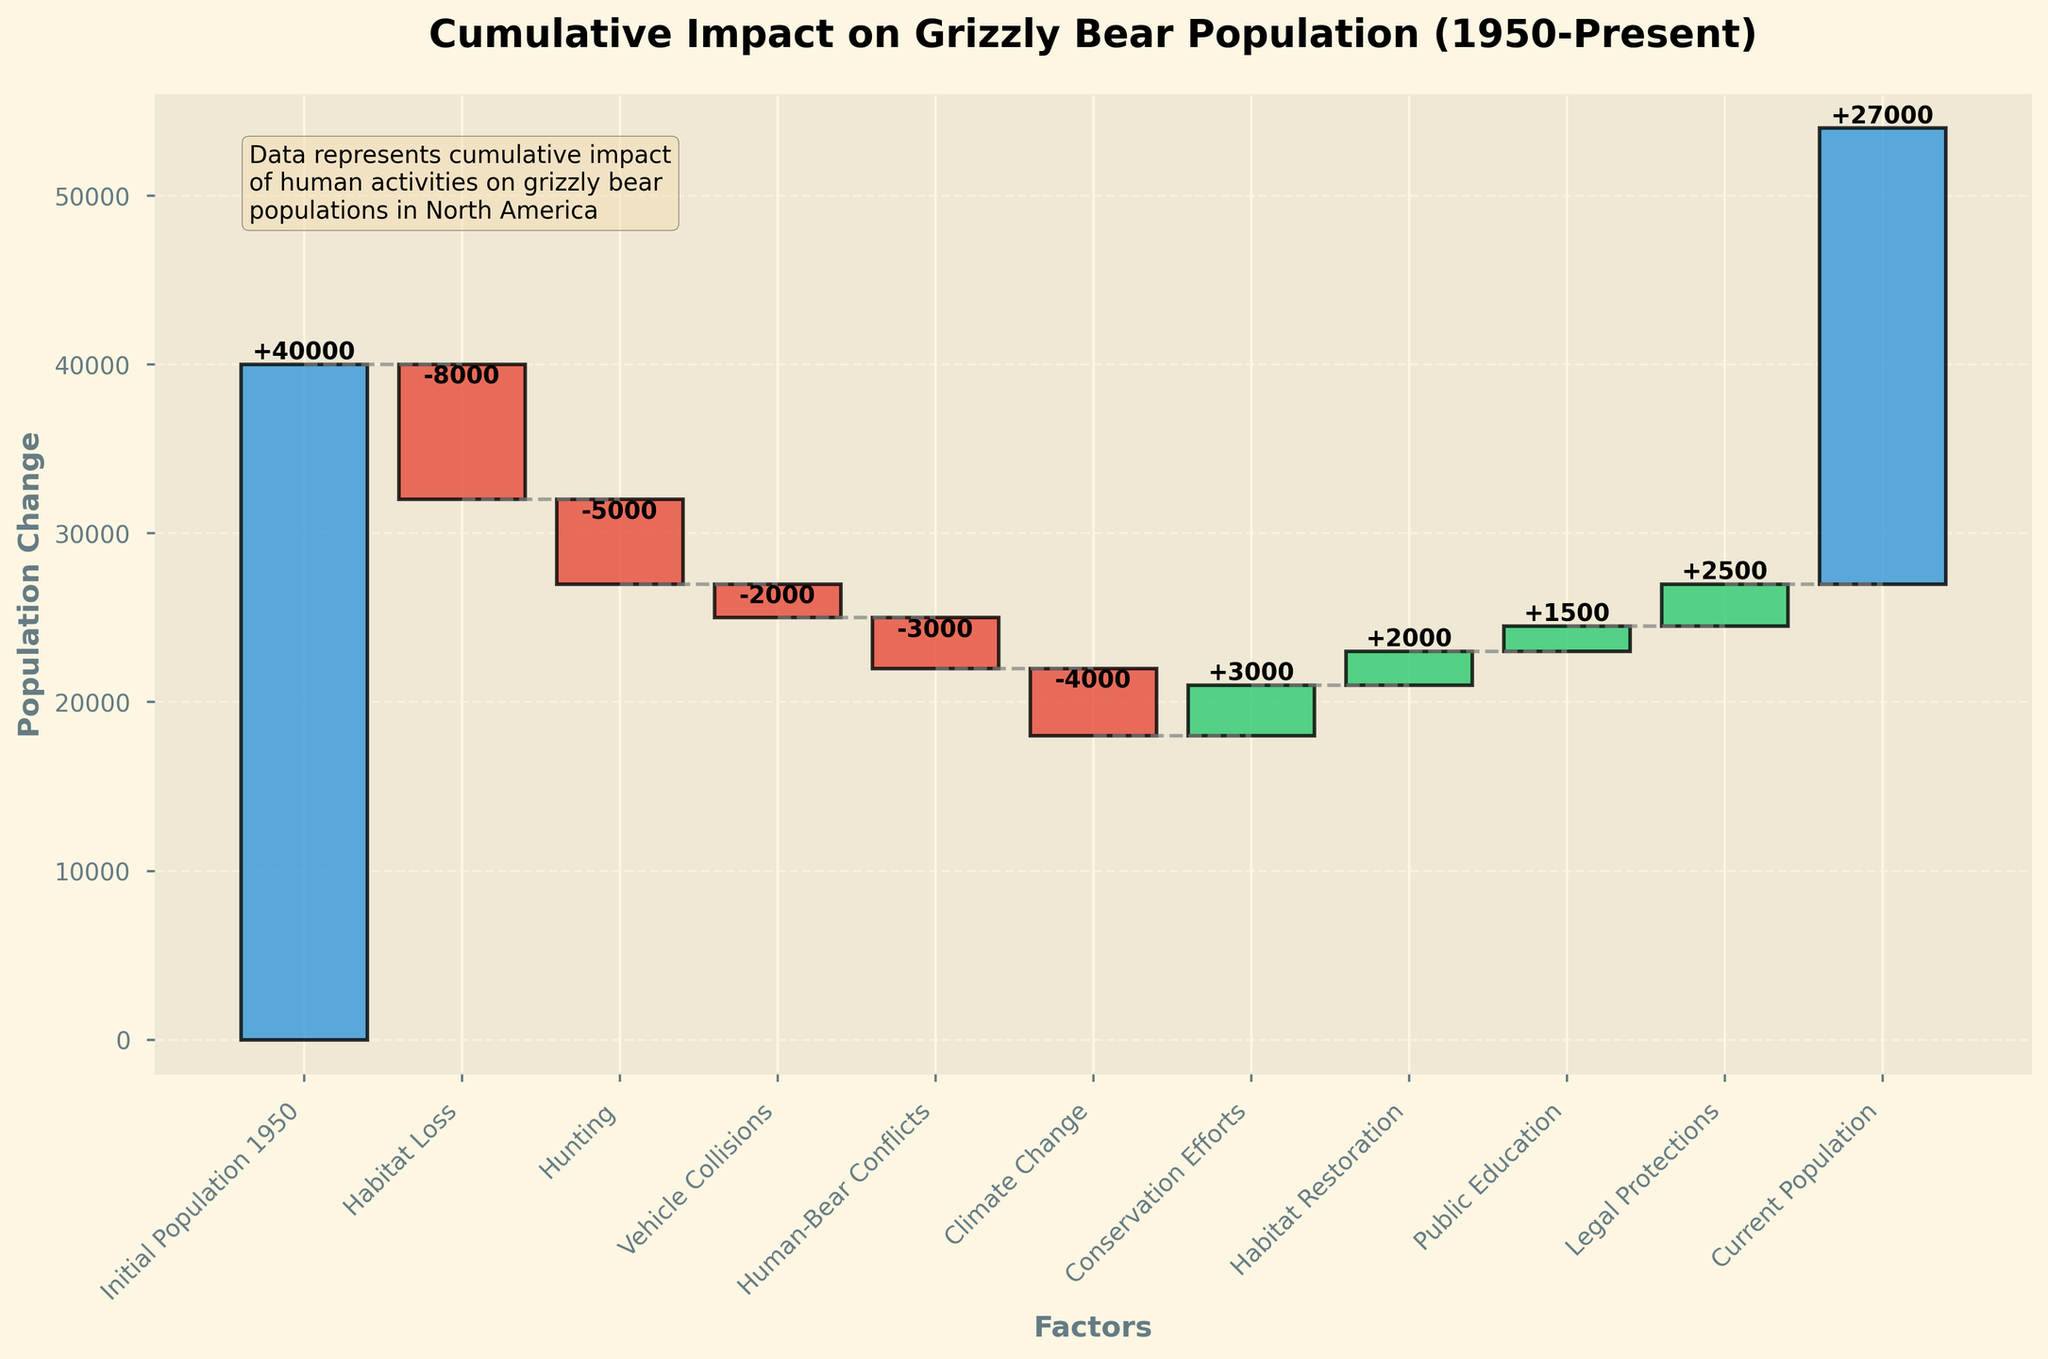What's the title of the chart? The chart title is typically located at the top and is written in bold for emphasis. Based on the data and context, it can be seen clearly.
Answer: "Cumulative Impact on Grizzly Bear Population (1950-Present)" What is the population of grizzly bears in 1950 according to the chart? The initial population value is usually the first data entry, serving as the baseline for the waterfall chart. Hence, it is found in the first bar on the left.
Answer: 40,000 What are the human activities that have negatively impacted the grizzly bear population? Activities leading to negative impacts are represented by bars going downward from the baseline, often indicated by a different color. Negative impacts are shown for Habitat Loss, Hunting, Vehicle Collisions, Human-Bear Conflicts, and Climate Change.
Answer: Habitat Loss, Hunting, Vehicle Collisions, Human-Bear Conflicts, Climate Change How much did conservation efforts contribute to the grizzly bear population recovery? For a positive impact, check the height of the upward bars starting from the cumulative negative impacts. The bar labeled "Conservation Efforts" shows this positive contribution.
Answer: 3,000 Which factor had the smallest negative impact on the grizzly bear population? Analyze the bars representing negative impacts. The length of these bars indicates the magnitude, and the shortest bar indicates the smallest negative impact. Vehicle Collisions shows the smallest negative impact.
Answer: Vehicle Collisions What is the overall cumulative impact of human activities on the grizzly bear population from 1950 until now? To find the cumulative impact, consider the initial and current populations and calculate the difference. Initial Population: 40,000; Current Population: 27,000. The cumulative impact is 40,000 - 27,000 = 13,000.
Answer: 13,000 How did legal protections influence the grizzly bear population according to the chart? Look for the bar indicating "Legal Protections". Positive impact bars are usually drawn upward from the cumulative total up to that point. The "Legal Protections" bar indicates an increase in population.
Answer: Increased by 2,500 Compare the impact of Habitat Loss and Climate Change on the grizzly bear population. Which had a greater impact? Both are negative impacts shown by downward bars; to compare, measure the length or value of each bar. Habitat Loss impacted by -8,000, whereas Climate Change impacted by -4,000. Habitat Loss had a greater negative impact.
Answer: Habitat Loss had a greater impact What is the current population of grizzly bears based on the chart? The current population is given by the final value or the last bar value on the right end of the chart.
Answer: 27,000 